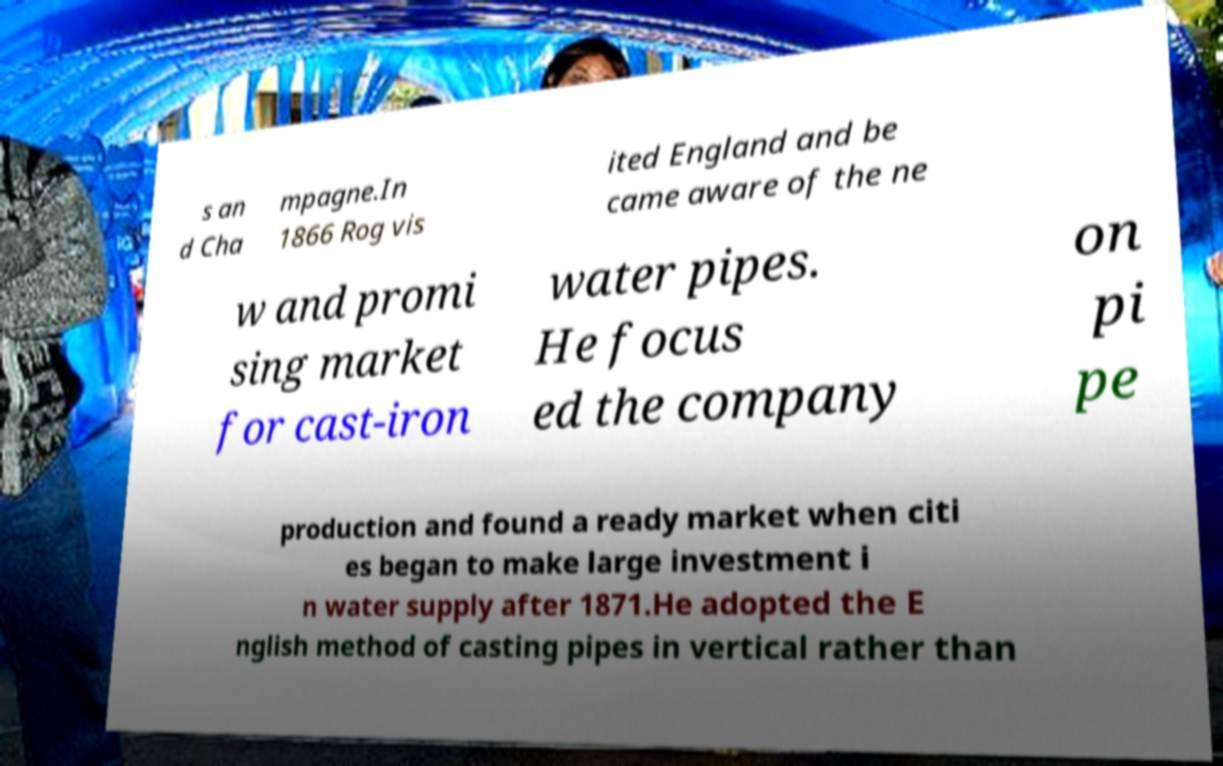I need the written content from this picture converted into text. Can you do that? s an d Cha mpagne.In 1866 Rog vis ited England and be came aware of the ne w and promi sing market for cast-iron water pipes. He focus ed the company on pi pe production and found a ready market when citi es began to make large investment i n water supply after 1871.He adopted the E nglish method of casting pipes in vertical rather than 